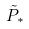Convert formula to latex. <formula><loc_0><loc_0><loc_500><loc_500>\tilde { P } _ { * }</formula> 